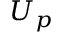Convert formula to latex. <formula><loc_0><loc_0><loc_500><loc_500>U _ { p }</formula> 